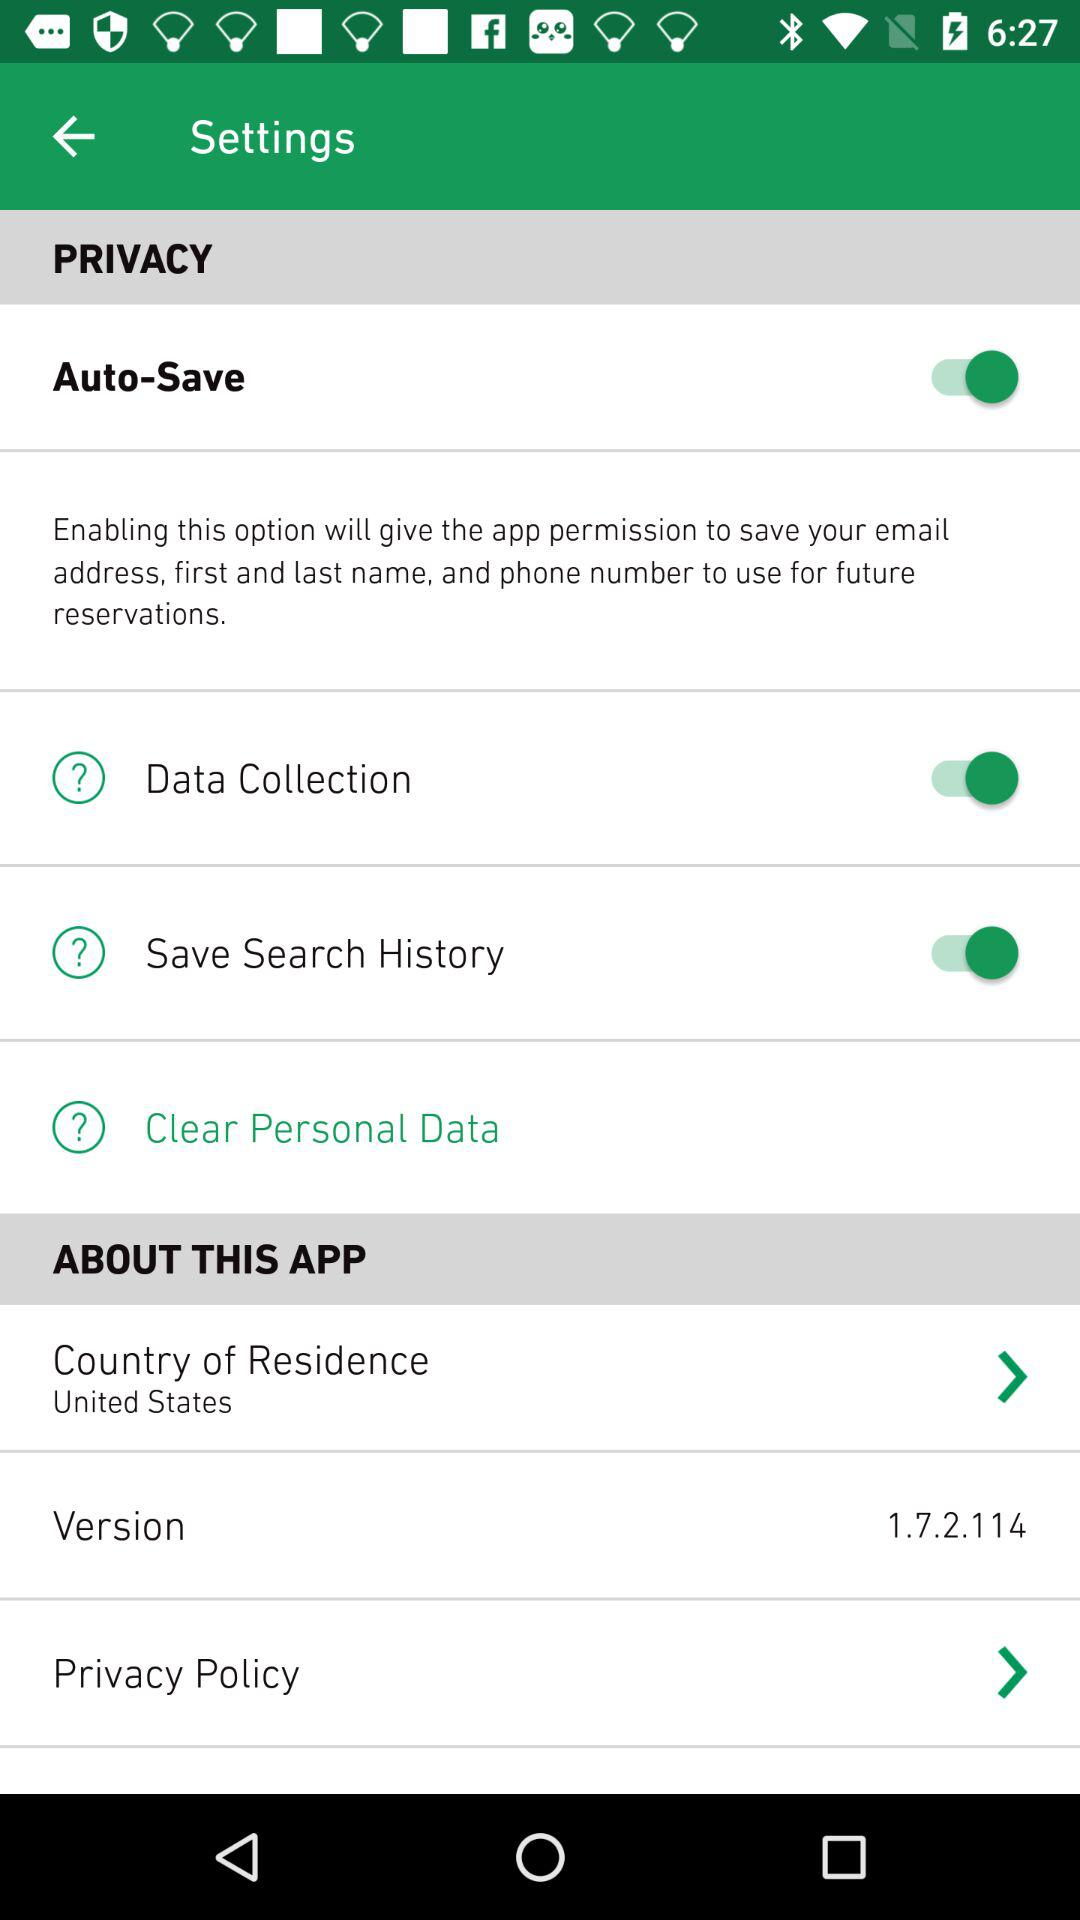What is the status of the "Auto-Save"? The status of the "Auto-Save" is "on". 